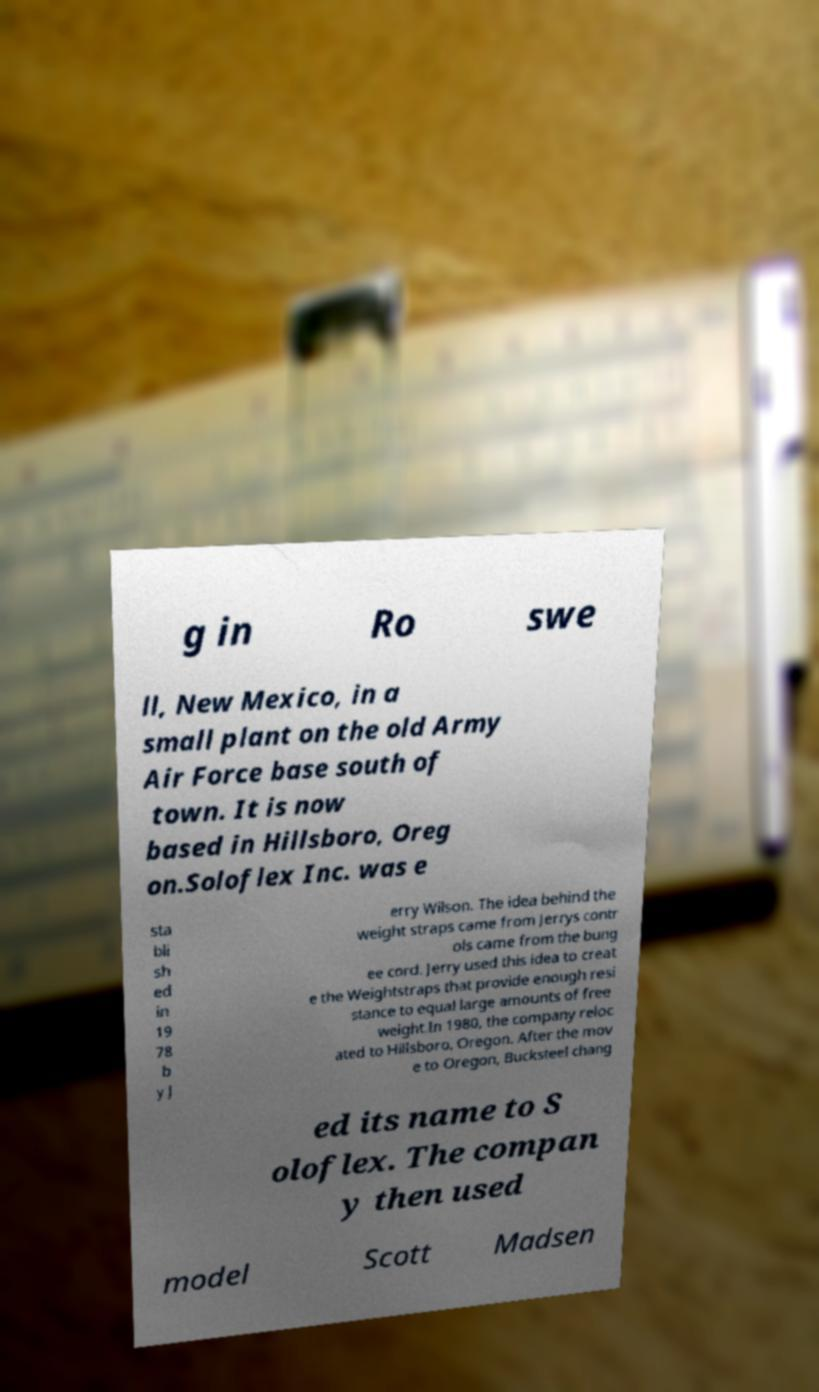Could you extract and type out the text from this image? g in Ro swe ll, New Mexico, in a small plant on the old Army Air Force base south of town. It is now based in Hillsboro, Oreg on.Soloflex Inc. was e sta bli sh ed in 19 78 b y J erry Wilson. The idea behind the weight straps came from Jerrys contr ols came from the bung ee cord. Jerry used this idea to creat e the Weightstraps that provide enough resi stance to equal large amounts of free weight.In 1980, the company reloc ated to Hillsboro, Oregon. After the mov e to Oregon, Bucksteel chang ed its name to S oloflex. The compan y then used model Scott Madsen 